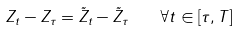<formula> <loc_0><loc_0><loc_500><loc_500>Z _ { t } - Z _ { \tau } = \tilde { Z } _ { t } - \tilde { Z } _ { \tau } \text {\quad } \forall t \in [ \tau , T ]</formula> 